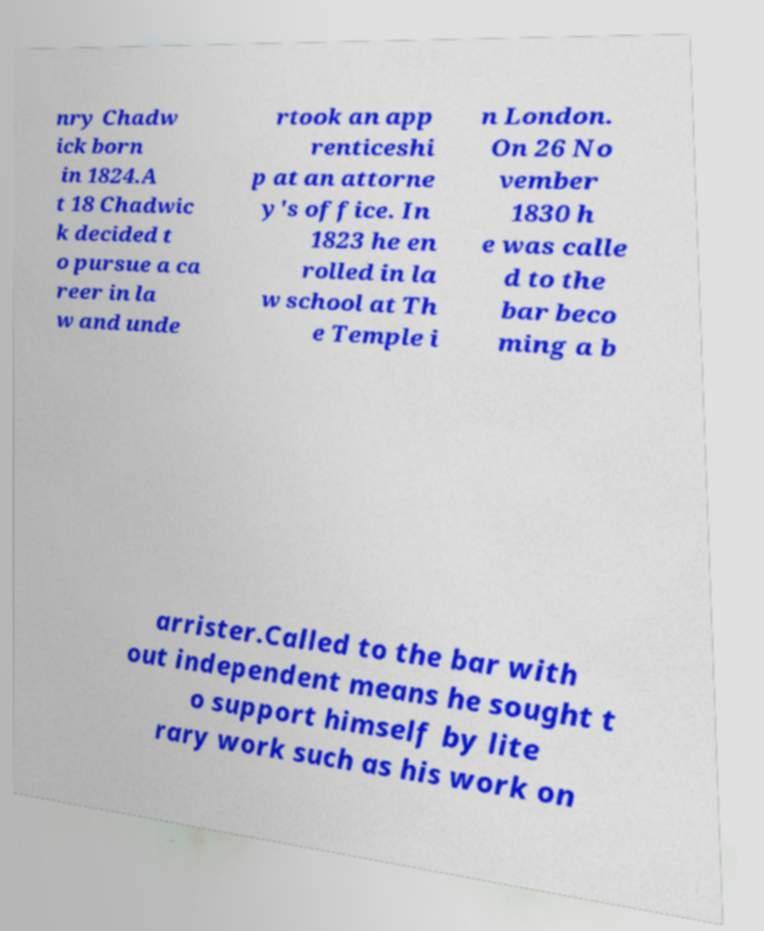What messages or text are displayed in this image? I need them in a readable, typed format. nry Chadw ick born in 1824.A t 18 Chadwic k decided t o pursue a ca reer in la w and unde rtook an app renticeshi p at an attorne y's office. In 1823 he en rolled in la w school at Th e Temple i n London. On 26 No vember 1830 h e was calle d to the bar beco ming a b arrister.Called to the bar with out independent means he sought t o support himself by lite rary work such as his work on 